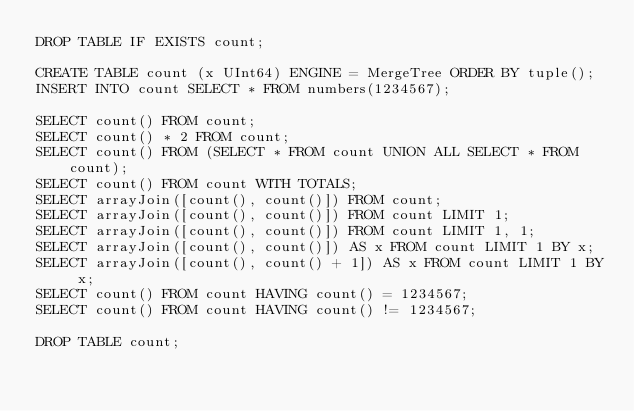Convert code to text. <code><loc_0><loc_0><loc_500><loc_500><_SQL_>DROP TABLE IF EXISTS count;

CREATE TABLE count (x UInt64) ENGINE = MergeTree ORDER BY tuple();
INSERT INTO count SELECT * FROM numbers(1234567);

SELECT count() FROM count;
SELECT count() * 2 FROM count;
SELECT count() FROM (SELECT * FROM count UNION ALL SELECT * FROM count);
SELECT count() FROM count WITH TOTALS;
SELECT arrayJoin([count(), count()]) FROM count;
SELECT arrayJoin([count(), count()]) FROM count LIMIT 1;
SELECT arrayJoin([count(), count()]) FROM count LIMIT 1, 1;
SELECT arrayJoin([count(), count()]) AS x FROM count LIMIT 1 BY x;
SELECT arrayJoin([count(), count() + 1]) AS x FROM count LIMIT 1 BY x;
SELECT count() FROM count HAVING count() = 1234567;
SELECT count() FROM count HAVING count() != 1234567;

DROP TABLE count;
</code> 